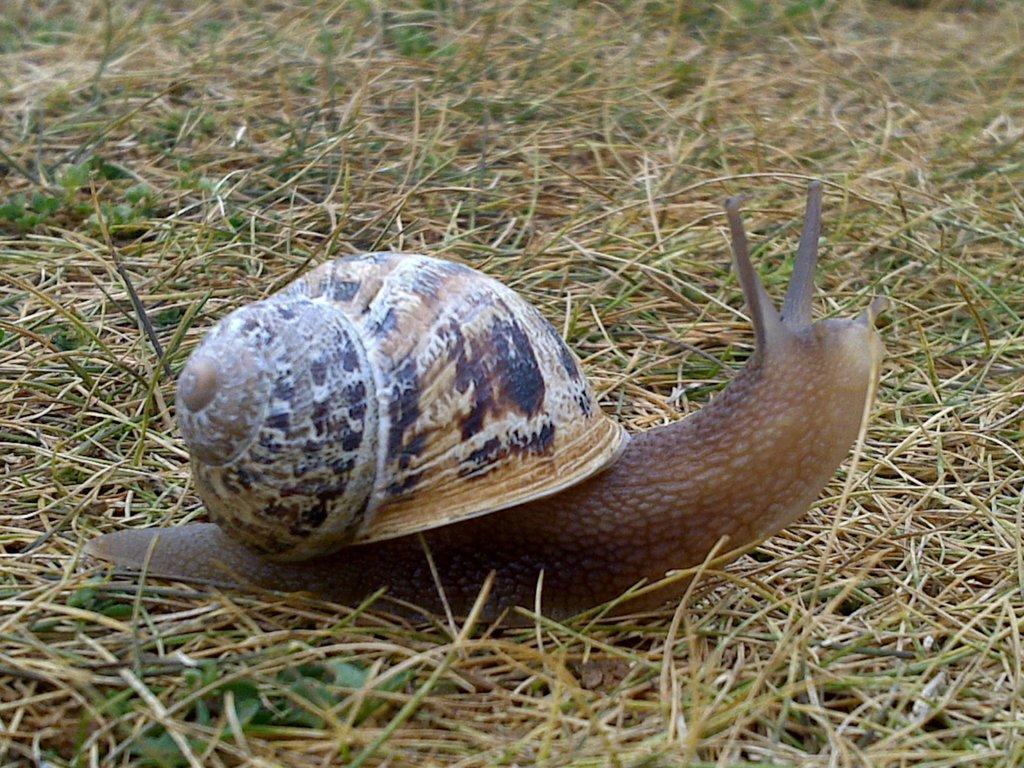Could you give a brief overview of what you see in this image? In this image we can see a snail. There is a grassy land in the image. 